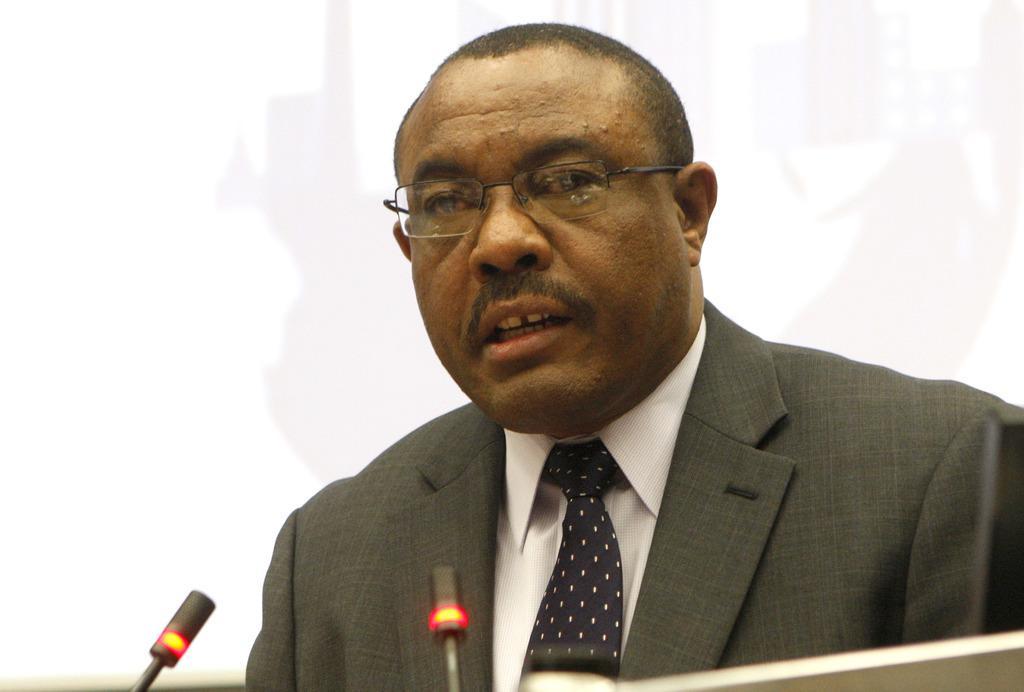Could you give a brief overview of what you see in this image? In this image in the middle, there is a man, he wears a suit, shirt, tie, in front of him there is a podium and mics. In the background there is a screen and wall. 